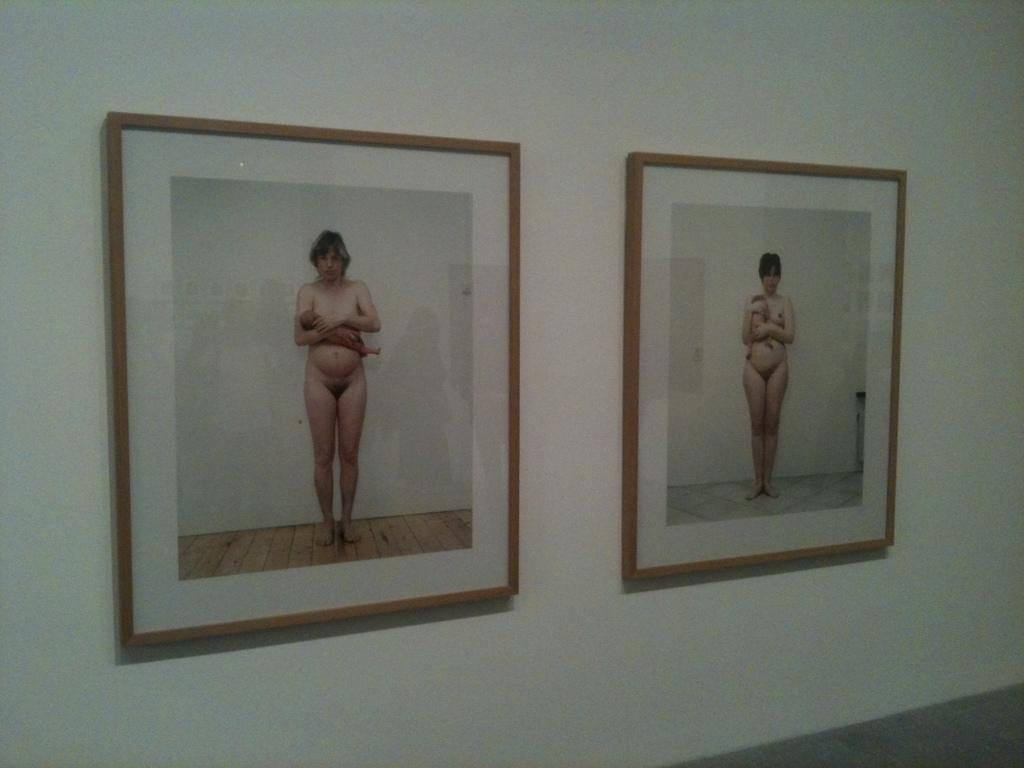What objects are present in the image that are typically used for displaying photos? There are photo frames in the image. Where are the photo frames located in the image? The photo frames are attached to the wall. What type of sink is visible in the image? There is no sink present in the image. What month is depicted in the photo frames in the image? The provided facts do not mention any specific month or time frame related to the photo frames. 